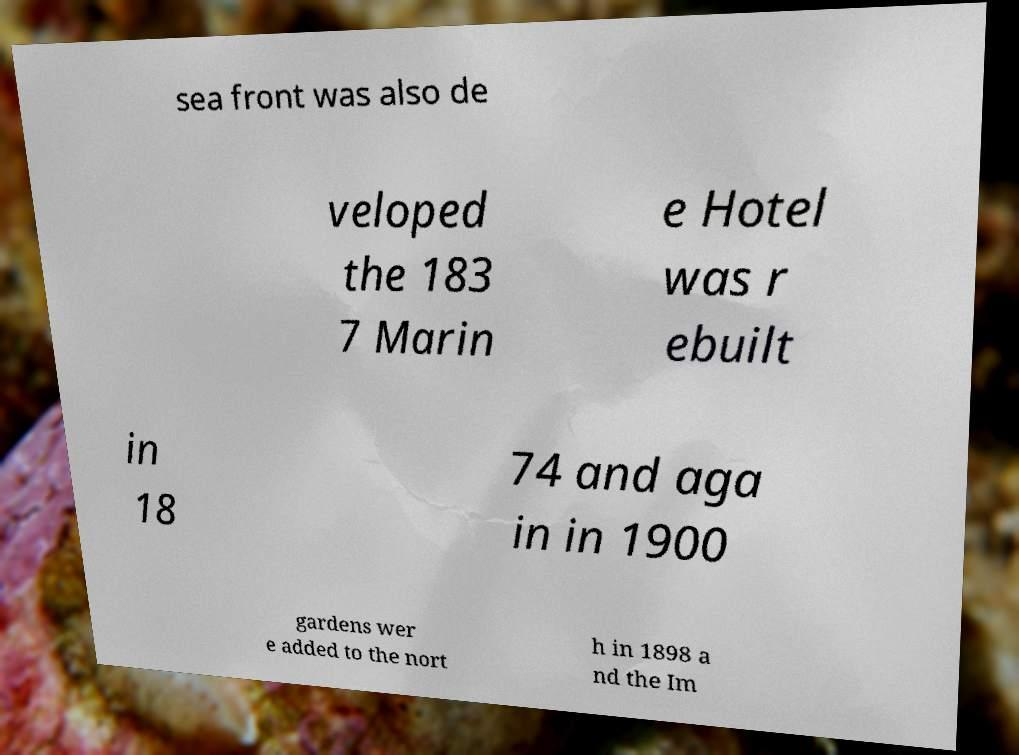For documentation purposes, I need the text within this image transcribed. Could you provide that? sea front was also de veloped the 183 7 Marin e Hotel was r ebuilt in 18 74 and aga in in 1900 gardens wer e added to the nort h in 1898 a nd the Im 